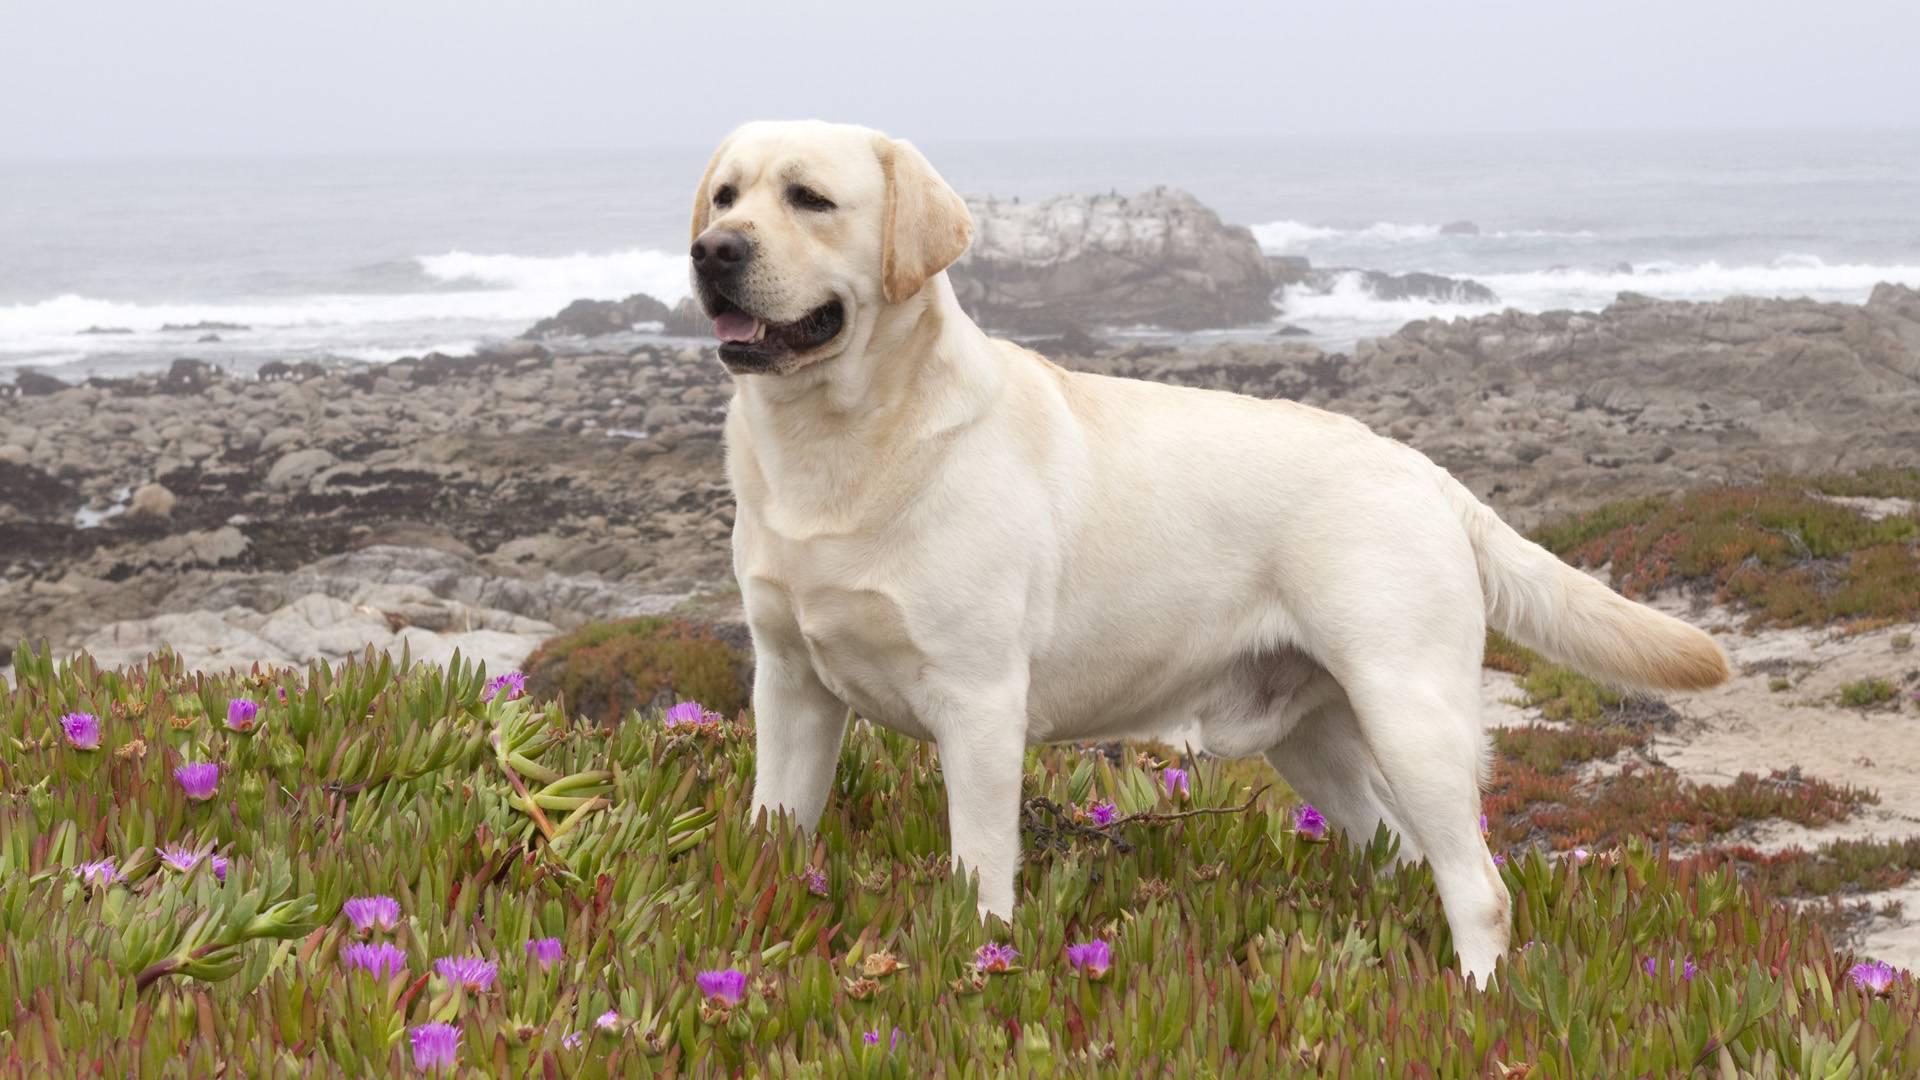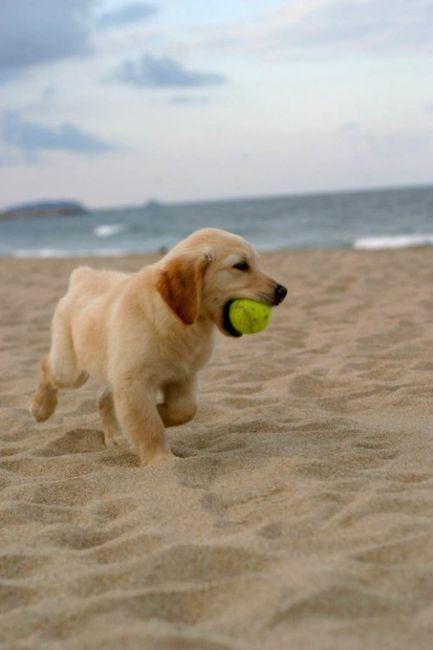The first image is the image on the left, the second image is the image on the right. Evaluate the accuracy of this statement regarding the images: "At least one dog has a green tennis ball.". Is it true? Answer yes or no. Yes. 